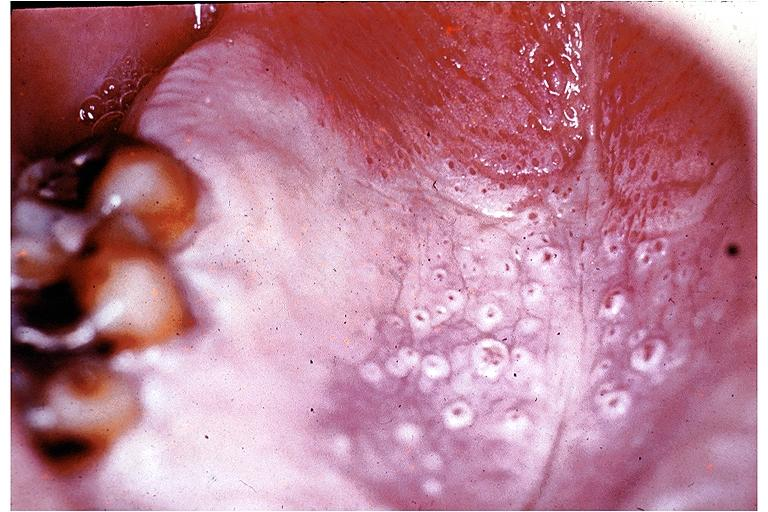what does this image show?
Answer the question using a single word or phrase. Nicotine stomatitis 